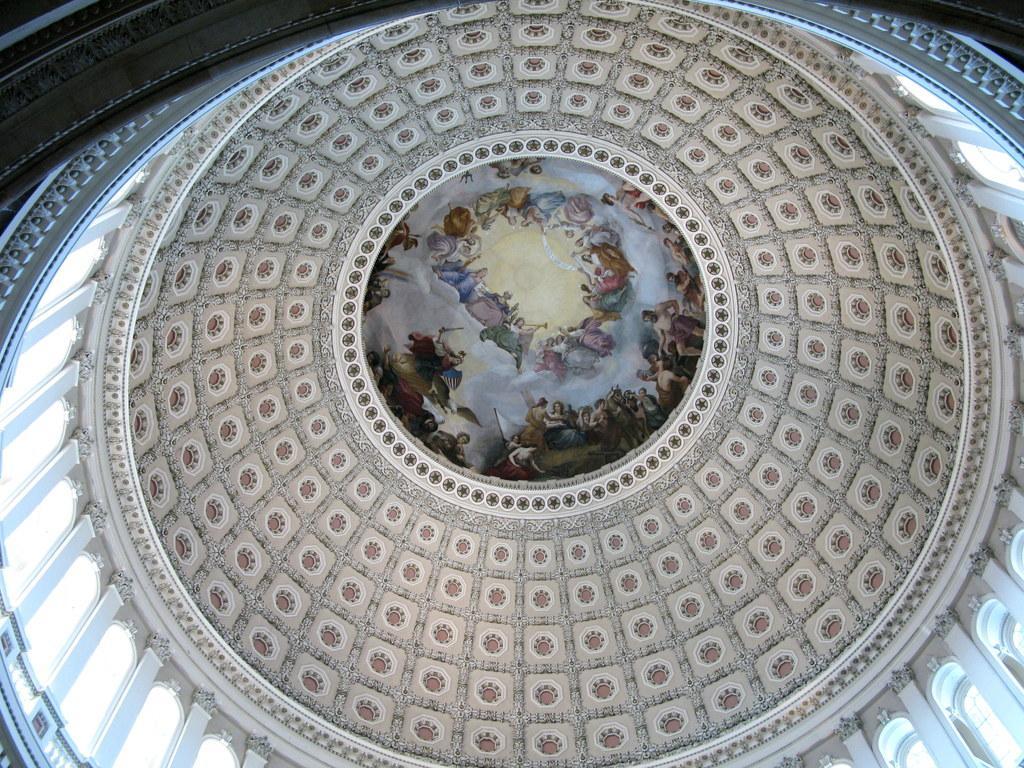Describe this image in one or two sentences. This is an inside view of a building and here we can see roof. 